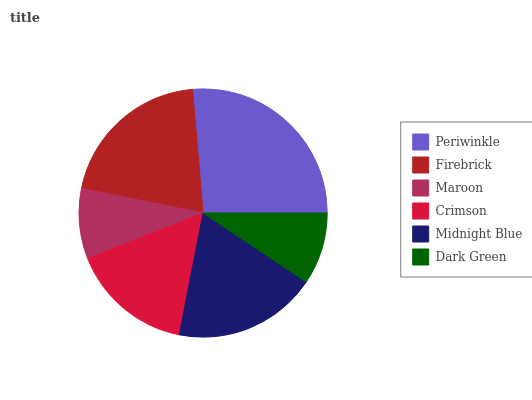Is Maroon the minimum?
Answer yes or no. Yes. Is Periwinkle the maximum?
Answer yes or no. Yes. Is Firebrick the minimum?
Answer yes or no. No. Is Firebrick the maximum?
Answer yes or no. No. Is Periwinkle greater than Firebrick?
Answer yes or no. Yes. Is Firebrick less than Periwinkle?
Answer yes or no. Yes. Is Firebrick greater than Periwinkle?
Answer yes or no. No. Is Periwinkle less than Firebrick?
Answer yes or no. No. Is Midnight Blue the high median?
Answer yes or no. Yes. Is Crimson the low median?
Answer yes or no. Yes. Is Crimson the high median?
Answer yes or no. No. Is Periwinkle the low median?
Answer yes or no. No. 